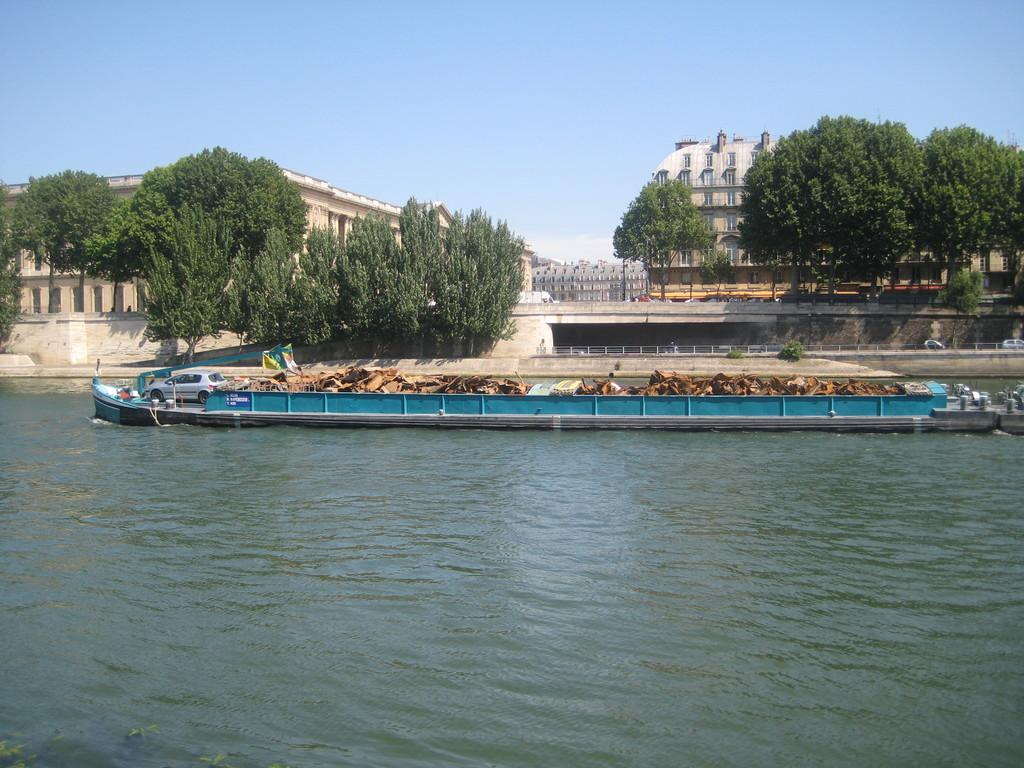What is at the bottom of the image? There is water at the bottom of the image. What type of vehicle is in the image? There is a car in the image. What can be seen in the background of the image? There are trees, buildings, and the sky visible in the background of the image. What direction is the dock facing in the image? There is no dock present in the image. What phase is the moon in the image? There is no moon present in the image. 